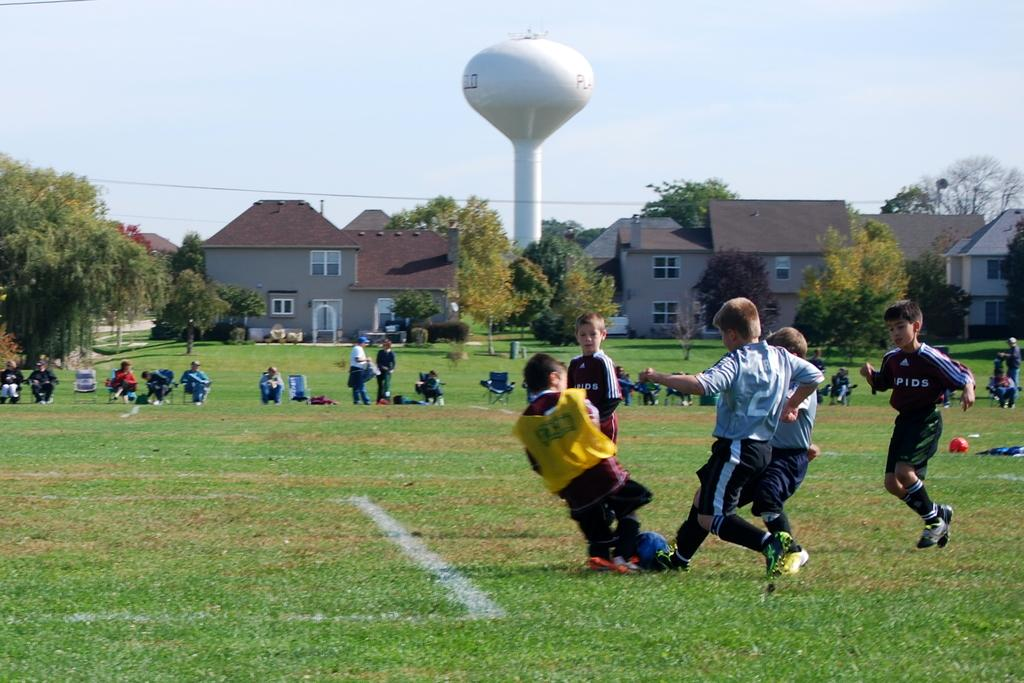What activity are the boys engaged in within the image? The boys are playing football in the image. What type of structures can be seen in the background? There are houses visible in the image. What type of vegetation is present in the image? There are trees present in the image. What type of rice is being used to play football in the image? There is no rice present in the image, and the boys are playing with a football, not rice. 